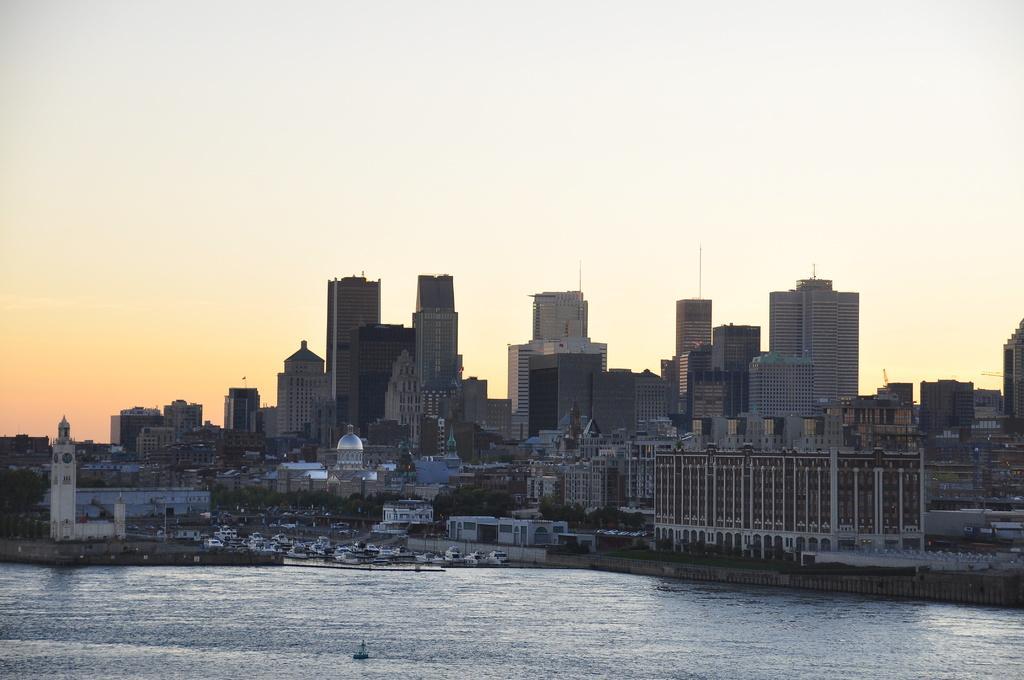In one or two sentences, can you explain what this image depicts? In this image we can see water. In the back there are buildings with windows and there are trees. In the background there is sky. 